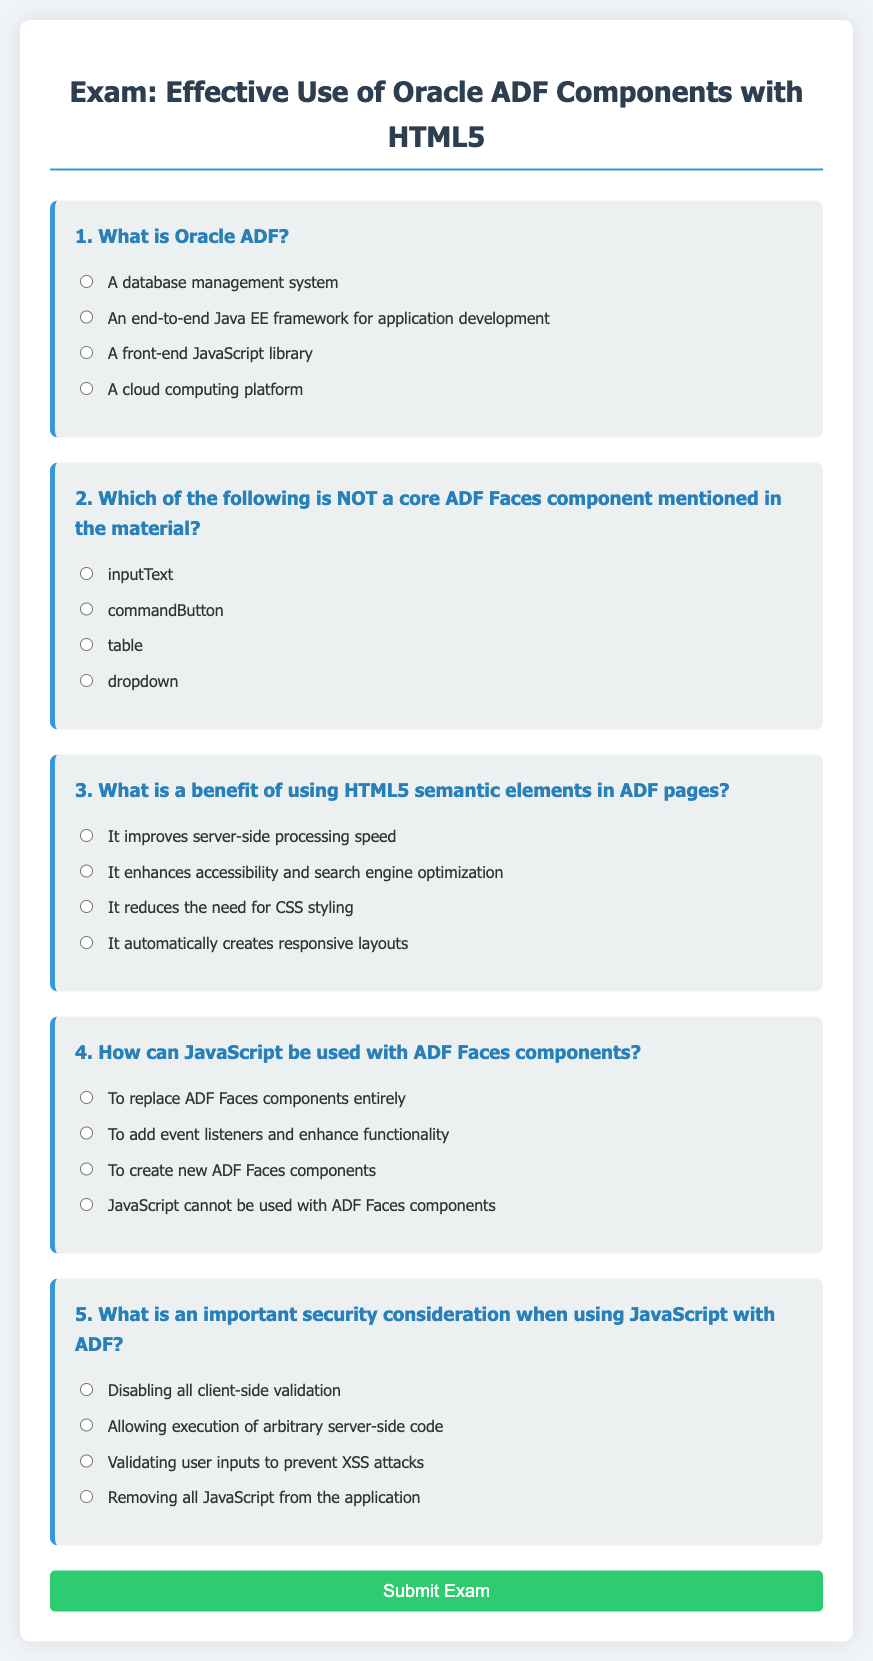What is the title of the exam? The title of the exam is indicated in the main heading of the document.
Answer: Effective Use of Oracle ADF Components with HTML5 How many questions are in the exam? The number of questions is determined by counting the distinct question sections in the document.
Answer: 5 What is the first question about? The first question addresses the definition and purpose of Oracle ADF as detailed in the content.
Answer: Oracle ADF Which option is provided for question two? Question two presents a list of options regarding ADF Faces components, specifically seeking the one that is not a core component.
Answer: dropdown What is the benefit of using HTML5 semantic elements according to the document? The document specifically states the advantages of HTML5 semantic elements in relation to web development.
Answer: enhances accessibility and search engine optimization What does the submit button say? The submit button's text is identified in the button element of the form.
Answer: Submit Exam What does the warning in the JavaScript section state? The warning in the JavaScript section indicates the action taken upon submitting the exam form.
Answer: Exam submitted! Your responses have been recorded 